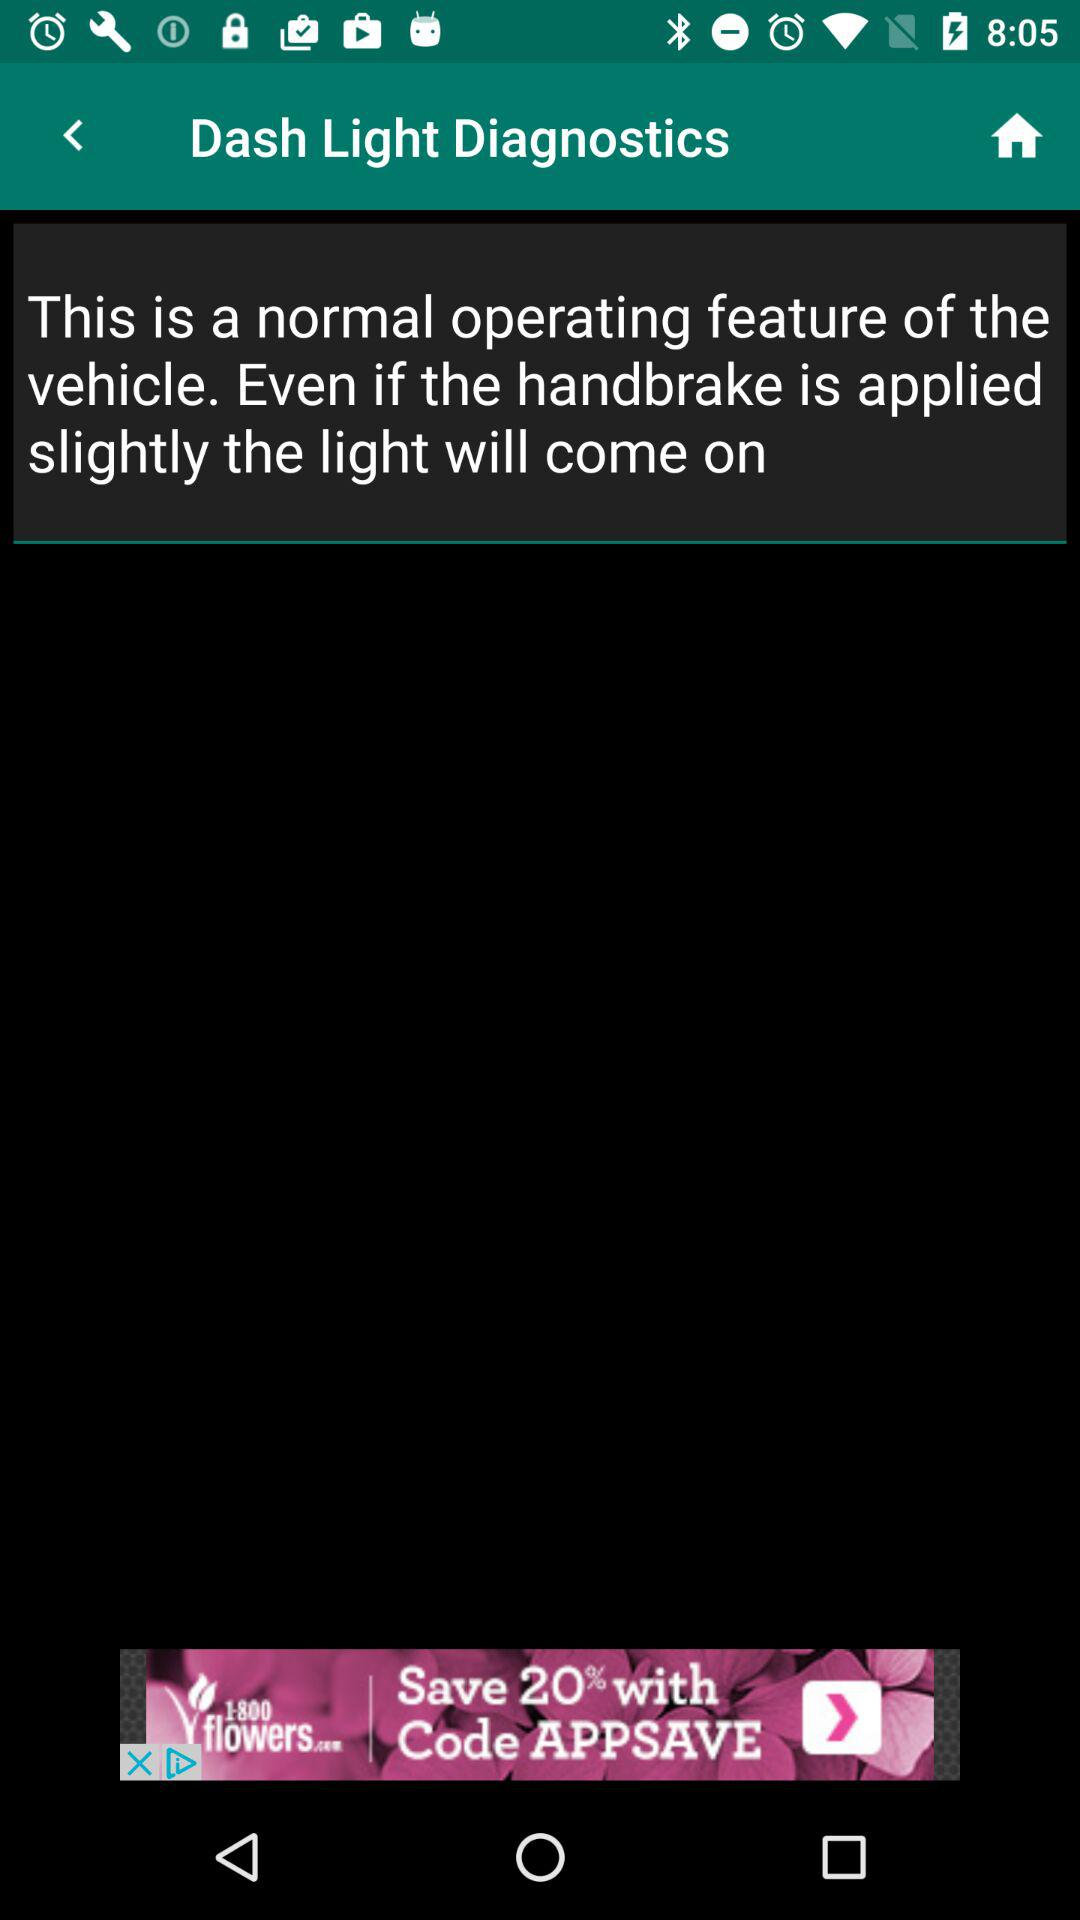What is the code?
When the provided information is insufficient, respond with <no answer>. <no answer> 